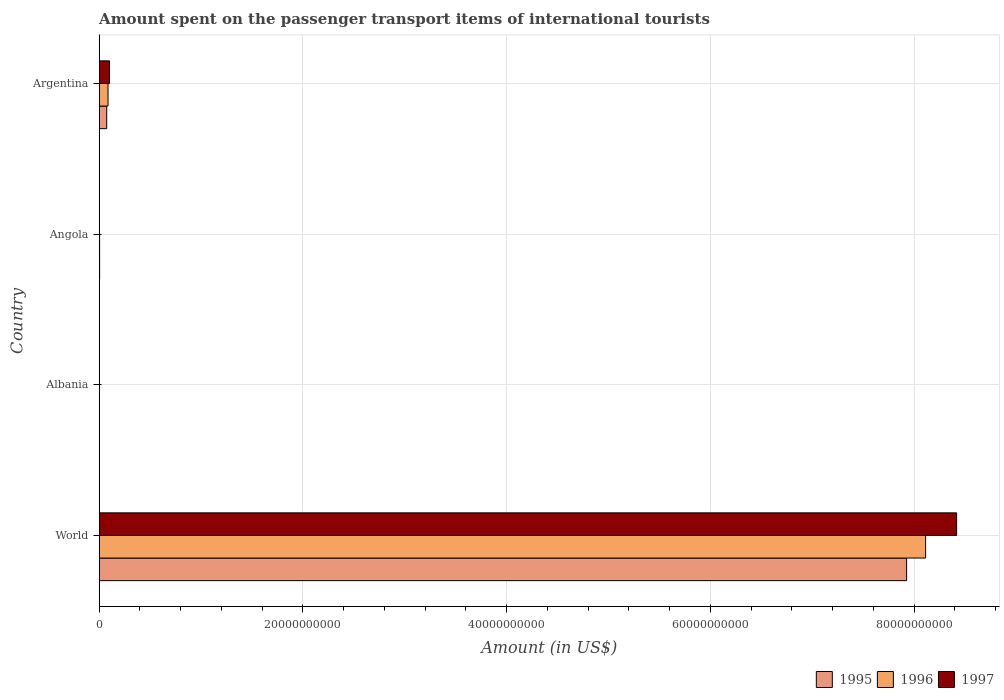How many different coloured bars are there?
Keep it short and to the point. 3. How many groups of bars are there?
Offer a very short reply. 4. Are the number of bars on each tick of the Y-axis equal?
Offer a very short reply. Yes. How many bars are there on the 1st tick from the top?
Your answer should be compact. 3. What is the label of the 2nd group of bars from the top?
Ensure brevity in your answer.  Angola. What is the amount spent on the passenger transport items of international tourists in 1995 in Argentina?
Your response must be concise. 7.35e+08. Across all countries, what is the maximum amount spent on the passenger transport items of international tourists in 1997?
Make the answer very short. 8.42e+1. In which country was the amount spent on the passenger transport items of international tourists in 1996 minimum?
Your answer should be compact. Albania. What is the total amount spent on the passenger transport items of international tourists in 1995 in the graph?
Make the answer very short. 8.00e+1. What is the difference between the amount spent on the passenger transport items of international tourists in 1995 in Albania and that in World?
Offer a very short reply. -7.92e+1. What is the difference between the amount spent on the passenger transport items of international tourists in 1995 in Argentina and the amount spent on the passenger transport items of international tourists in 1997 in World?
Offer a very short reply. -8.34e+1. What is the average amount spent on the passenger transport items of international tourists in 1997 per country?
Offer a terse response. 2.13e+1. What is the ratio of the amount spent on the passenger transport items of international tourists in 1997 in Argentina to that in World?
Provide a short and direct response. 0.01. Is the difference between the amount spent on the passenger transport items of international tourists in 1996 in Albania and Angola greater than the difference between the amount spent on the passenger transport items of international tourists in 1997 in Albania and Angola?
Your answer should be compact. No. What is the difference between the highest and the second highest amount spent on the passenger transport items of international tourists in 1995?
Offer a very short reply. 7.85e+1. What is the difference between the highest and the lowest amount spent on the passenger transport items of international tourists in 1996?
Provide a succinct answer. 8.11e+1. In how many countries, is the amount spent on the passenger transport items of international tourists in 1997 greater than the average amount spent on the passenger transport items of international tourists in 1997 taken over all countries?
Your answer should be very brief. 1. Is it the case that in every country, the sum of the amount spent on the passenger transport items of international tourists in 1995 and amount spent on the passenger transport items of international tourists in 1996 is greater than the amount spent on the passenger transport items of international tourists in 1997?
Offer a terse response. Yes. Are the values on the major ticks of X-axis written in scientific E-notation?
Provide a succinct answer. No. How are the legend labels stacked?
Keep it short and to the point. Horizontal. What is the title of the graph?
Your answer should be very brief. Amount spent on the passenger transport items of international tourists. Does "2010" appear as one of the legend labels in the graph?
Your answer should be compact. No. What is the label or title of the X-axis?
Ensure brevity in your answer.  Amount (in US$). What is the label or title of the Y-axis?
Your answer should be compact. Country. What is the Amount (in US$) of 1995 in World?
Offer a terse response. 7.93e+1. What is the Amount (in US$) of 1996 in World?
Your answer should be very brief. 8.11e+1. What is the Amount (in US$) of 1997 in World?
Offer a terse response. 8.42e+1. What is the Amount (in US$) of 1995 in Albania?
Your answer should be very brief. 1.20e+07. What is the Amount (in US$) of 1996 in Albania?
Make the answer very short. 1.30e+07. What is the Amount (in US$) in 1997 in Albania?
Make the answer very short. 8.00e+06. What is the Amount (in US$) in 1995 in Angola?
Give a very brief answer. 3.78e+07. What is the Amount (in US$) of 1996 in Angola?
Make the answer very short. 3.74e+07. What is the Amount (in US$) in 1997 in Angola?
Your answer should be very brief. 2.72e+07. What is the Amount (in US$) of 1995 in Argentina?
Offer a very short reply. 7.35e+08. What is the Amount (in US$) in 1996 in Argentina?
Offer a terse response. 8.65e+08. What is the Amount (in US$) of 1997 in Argentina?
Your answer should be very brief. 1.01e+09. Across all countries, what is the maximum Amount (in US$) of 1995?
Provide a succinct answer. 7.93e+1. Across all countries, what is the maximum Amount (in US$) of 1996?
Your answer should be compact. 8.11e+1. Across all countries, what is the maximum Amount (in US$) of 1997?
Offer a very short reply. 8.42e+1. Across all countries, what is the minimum Amount (in US$) of 1996?
Keep it short and to the point. 1.30e+07. Across all countries, what is the minimum Amount (in US$) in 1997?
Your response must be concise. 8.00e+06. What is the total Amount (in US$) in 1995 in the graph?
Your answer should be compact. 8.00e+1. What is the total Amount (in US$) in 1996 in the graph?
Ensure brevity in your answer.  8.20e+1. What is the total Amount (in US$) of 1997 in the graph?
Make the answer very short. 8.52e+1. What is the difference between the Amount (in US$) in 1995 in World and that in Albania?
Offer a very short reply. 7.92e+1. What is the difference between the Amount (in US$) of 1996 in World and that in Albania?
Your answer should be compact. 8.11e+1. What is the difference between the Amount (in US$) of 1997 in World and that in Albania?
Offer a terse response. 8.42e+1. What is the difference between the Amount (in US$) of 1995 in World and that in Angola?
Provide a succinct answer. 7.92e+1. What is the difference between the Amount (in US$) in 1996 in World and that in Angola?
Offer a very short reply. 8.11e+1. What is the difference between the Amount (in US$) of 1997 in World and that in Angola?
Provide a short and direct response. 8.41e+1. What is the difference between the Amount (in US$) in 1995 in World and that in Argentina?
Provide a short and direct response. 7.85e+1. What is the difference between the Amount (in US$) of 1996 in World and that in Argentina?
Provide a succinct answer. 8.03e+1. What is the difference between the Amount (in US$) of 1997 in World and that in Argentina?
Ensure brevity in your answer.  8.32e+1. What is the difference between the Amount (in US$) of 1995 in Albania and that in Angola?
Offer a very short reply. -2.58e+07. What is the difference between the Amount (in US$) in 1996 in Albania and that in Angola?
Make the answer very short. -2.44e+07. What is the difference between the Amount (in US$) in 1997 in Albania and that in Angola?
Give a very brief answer. -1.92e+07. What is the difference between the Amount (in US$) in 1995 in Albania and that in Argentina?
Keep it short and to the point. -7.23e+08. What is the difference between the Amount (in US$) of 1996 in Albania and that in Argentina?
Your answer should be very brief. -8.52e+08. What is the difference between the Amount (in US$) in 1997 in Albania and that in Argentina?
Give a very brief answer. -1.00e+09. What is the difference between the Amount (in US$) of 1995 in Angola and that in Argentina?
Your response must be concise. -6.97e+08. What is the difference between the Amount (in US$) in 1996 in Angola and that in Argentina?
Give a very brief answer. -8.28e+08. What is the difference between the Amount (in US$) in 1997 in Angola and that in Argentina?
Provide a succinct answer. -9.84e+08. What is the difference between the Amount (in US$) of 1995 in World and the Amount (in US$) of 1996 in Albania?
Your answer should be very brief. 7.92e+1. What is the difference between the Amount (in US$) of 1995 in World and the Amount (in US$) of 1997 in Albania?
Offer a very short reply. 7.92e+1. What is the difference between the Amount (in US$) in 1996 in World and the Amount (in US$) in 1997 in Albania?
Offer a terse response. 8.11e+1. What is the difference between the Amount (in US$) of 1995 in World and the Amount (in US$) of 1996 in Angola?
Give a very brief answer. 7.92e+1. What is the difference between the Amount (in US$) of 1995 in World and the Amount (in US$) of 1997 in Angola?
Your answer should be very brief. 7.92e+1. What is the difference between the Amount (in US$) in 1996 in World and the Amount (in US$) in 1997 in Angola?
Give a very brief answer. 8.11e+1. What is the difference between the Amount (in US$) of 1995 in World and the Amount (in US$) of 1996 in Argentina?
Provide a short and direct response. 7.84e+1. What is the difference between the Amount (in US$) of 1995 in World and the Amount (in US$) of 1997 in Argentina?
Your answer should be very brief. 7.82e+1. What is the difference between the Amount (in US$) in 1996 in World and the Amount (in US$) in 1997 in Argentina?
Offer a very short reply. 8.01e+1. What is the difference between the Amount (in US$) in 1995 in Albania and the Amount (in US$) in 1996 in Angola?
Make the answer very short. -2.54e+07. What is the difference between the Amount (in US$) in 1995 in Albania and the Amount (in US$) in 1997 in Angola?
Ensure brevity in your answer.  -1.52e+07. What is the difference between the Amount (in US$) of 1996 in Albania and the Amount (in US$) of 1997 in Angola?
Your response must be concise. -1.42e+07. What is the difference between the Amount (in US$) in 1995 in Albania and the Amount (in US$) in 1996 in Argentina?
Make the answer very short. -8.53e+08. What is the difference between the Amount (in US$) in 1995 in Albania and the Amount (in US$) in 1997 in Argentina?
Offer a terse response. -9.99e+08. What is the difference between the Amount (in US$) in 1996 in Albania and the Amount (in US$) in 1997 in Argentina?
Offer a very short reply. -9.98e+08. What is the difference between the Amount (in US$) of 1995 in Angola and the Amount (in US$) of 1996 in Argentina?
Provide a short and direct response. -8.27e+08. What is the difference between the Amount (in US$) of 1995 in Angola and the Amount (in US$) of 1997 in Argentina?
Your answer should be compact. -9.73e+08. What is the difference between the Amount (in US$) of 1996 in Angola and the Amount (in US$) of 1997 in Argentina?
Your answer should be compact. -9.74e+08. What is the average Amount (in US$) in 1995 per country?
Provide a succinct answer. 2.00e+1. What is the average Amount (in US$) in 1996 per country?
Offer a terse response. 2.05e+1. What is the average Amount (in US$) of 1997 per country?
Make the answer very short. 2.13e+1. What is the difference between the Amount (in US$) of 1995 and Amount (in US$) of 1996 in World?
Offer a terse response. -1.87e+09. What is the difference between the Amount (in US$) in 1995 and Amount (in US$) in 1997 in World?
Offer a very short reply. -4.91e+09. What is the difference between the Amount (in US$) in 1996 and Amount (in US$) in 1997 in World?
Offer a terse response. -3.04e+09. What is the difference between the Amount (in US$) in 1996 and Amount (in US$) in 1997 in Albania?
Ensure brevity in your answer.  5.00e+06. What is the difference between the Amount (in US$) in 1995 and Amount (in US$) in 1996 in Angola?
Provide a succinct answer. 4.50e+05. What is the difference between the Amount (in US$) of 1995 and Amount (in US$) of 1997 in Angola?
Your answer should be compact. 1.06e+07. What is the difference between the Amount (in US$) in 1996 and Amount (in US$) in 1997 in Angola?
Keep it short and to the point. 1.02e+07. What is the difference between the Amount (in US$) of 1995 and Amount (in US$) of 1996 in Argentina?
Make the answer very short. -1.30e+08. What is the difference between the Amount (in US$) of 1995 and Amount (in US$) of 1997 in Argentina?
Make the answer very short. -2.76e+08. What is the difference between the Amount (in US$) in 1996 and Amount (in US$) in 1997 in Argentina?
Keep it short and to the point. -1.46e+08. What is the ratio of the Amount (in US$) of 1995 in World to that in Albania?
Offer a very short reply. 6604.42. What is the ratio of the Amount (in US$) of 1996 in World to that in Albania?
Provide a short and direct response. 6239.88. What is the ratio of the Amount (in US$) in 1997 in World to that in Albania?
Provide a short and direct response. 1.05e+04. What is the ratio of the Amount (in US$) of 1995 in World to that in Angola?
Provide a succinct answer. 2095.59. What is the ratio of the Amount (in US$) in 1996 in World to that in Angola?
Offer a terse response. 2170.74. What is the ratio of the Amount (in US$) in 1997 in World to that in Angola?
Offer a terse response. 3094.22. What is the ratio of the Amount (in US$) of 1995 in World to that in Argentina?
Offer a terse response. 107.83. What is the ratio of the Amount (in US$) of 1996 in World to that in Argentina?
Keep it short and to the point. 93.78. What is the ratio of the Amount (in US$) of 1997 in World to that in Argentina?
Provide a short and direct response. 83.25. What is the ratio of the Amount (in US$) of 1995 in Albania to that in Angola?
Your answer should be compact. 0.32. What is the ratio of the Amount (in US$) of 1996 in Albania to that in Angola?
Provide a succinct answer. 0.35. What is the ratio of the Amount (in US$) of 1997 in Albania to that in Angola?
Offer a terse response. 0.29. What is the ratio of the Amount (in US$) of 1995 in Albania to that in Argentina?
Make the answer very short. 0.02. What is the ratio of the Amount (in US$) in 1996 in Albania to that in Argentina?
Provide a short and direct response. 0.01. What is the ratio of the Amount (in US$) in 1997 in Albania to that in Argentina?
Provide a short and direct response. 0.01. What is the ratio of the Amount (in US$) of 1995 in Angola to that in Argentina?
Give a very brief answer. 0.05. What is the ratio of the Amount (in US$) of 1996 in Angola to that in Argentina?
Offer a very short reply. 0.04. What is the ratio of the Amount (in US$) in 1997 in Angola to that in Argentina?
Your answer should be compact. 0.03. What is the difference between the highest and the second highest Amount (in US$) in 1995?
Your response must be concise. 7.85e+1. What is the difference between the highest and the second highest Amount (in US$) in 1996?
Your answer should be compact. 8.03e+1. What is the difference between the highest and the second highest Amount (in US$) in 1997?
Your response must be concise. 8.32e+1. What is the difference between the highest and the lowest Amount (in US$) of 1995?
Your response must be concise. 7.92e+1. What is the difference between the highest and the lowest Amount (in US$) of 1996?
Make the answer very short. 8.11e+1. What is the difference between the highest and the lowest Amount (in US$) in 1997?
Keep it short and to the point. 8.42e+1. 